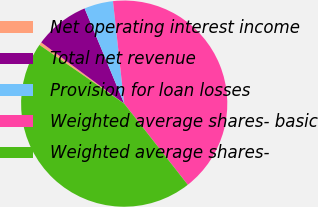Convert chart to OTSL. <chart><loc_0><loc_0><loc_500><loc_500><pie_chart><fcel>Net operating interest income<fcel>Total net revenue<fcel>Provision for loan losses<fcel>Weighted average shares- basic<fcel>Weighted average shares-<nl><fcel>0.47%<fcel>8.61%<fcel>4.54%<fcel>41.15%<fcel>45.22%<nl></chart> 